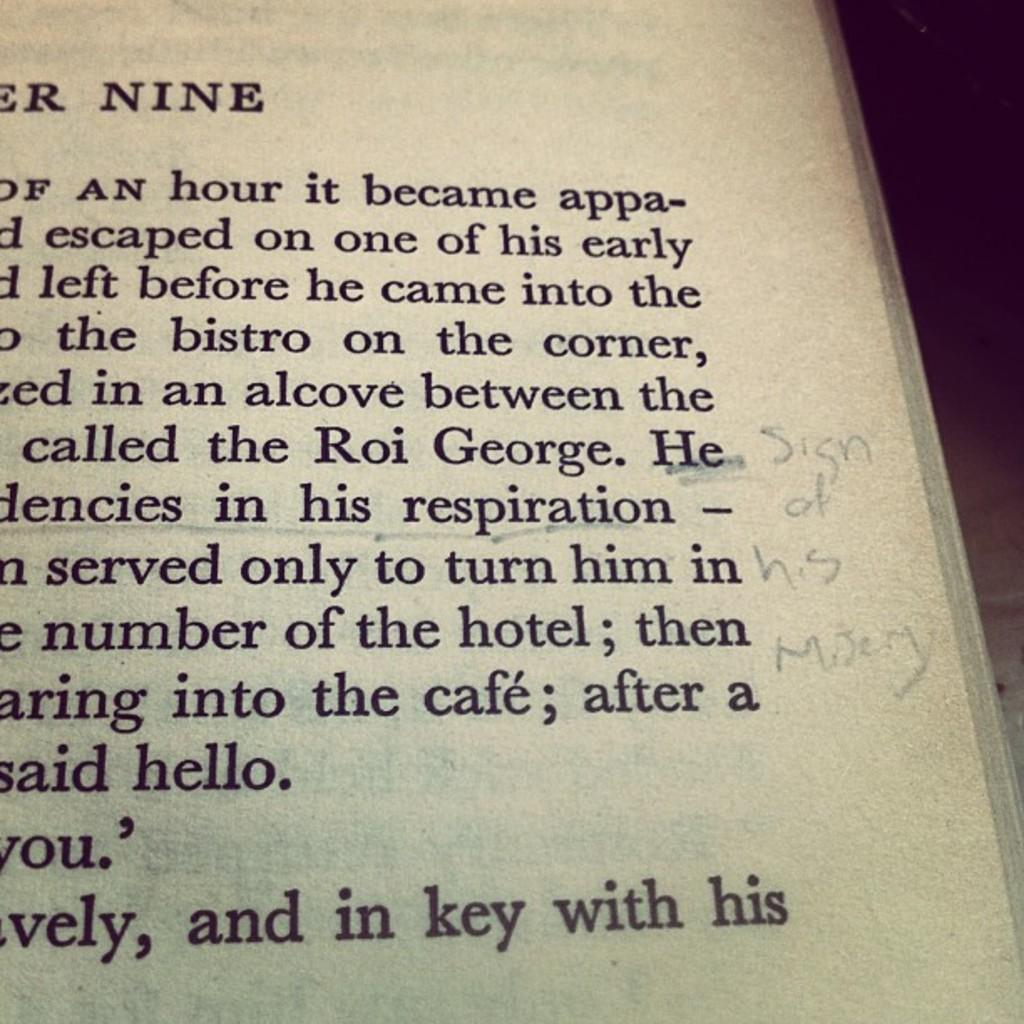<image>
Give a short and clear explanation of the subsequent image. The corner of a book page with the writings 'Sign of his misery.' 